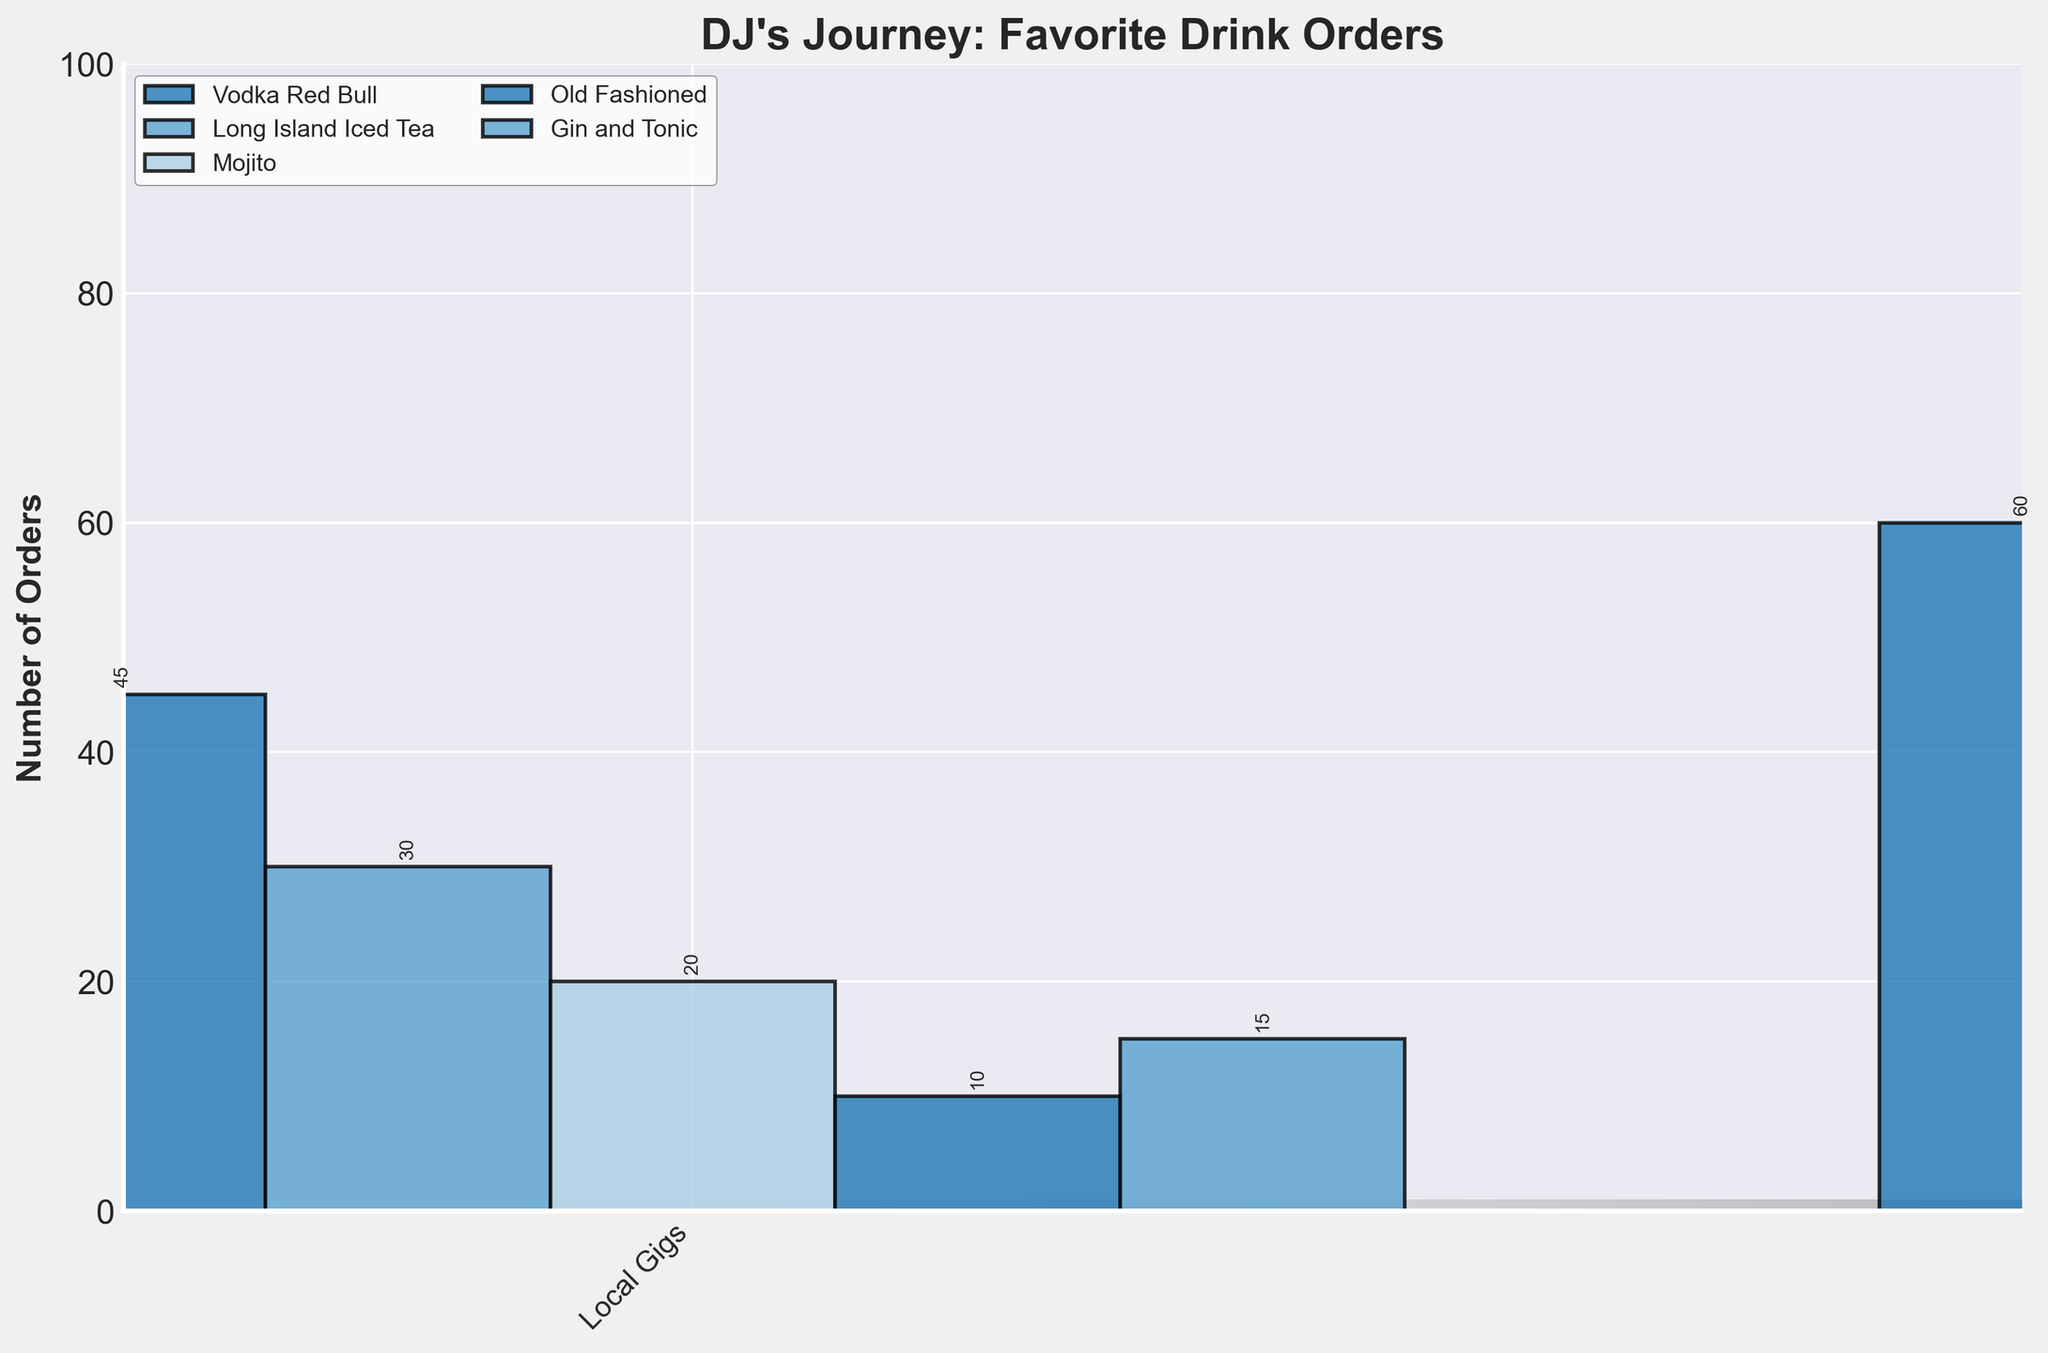Which drink had the most orders during the Grammy Nomination stage? Look for the highest bar in the Grammy Nomination stage section of the plot. The highest bar represents Old Fashioned.
Answer: Old Fashioned What is the total number of orders for Mojitos during Festival Appearances and International Tours stages combined? Sum the Mojito orders at these two stages: 50 (Festival Appearances) + 60 (International Tours) = 110
Answer: 110 How does the number of Old Fashioned orders change from Club Residency to International Tours stages? Subtract the Old Fashioned orders at Club Residency (25) from those at International Tours (55): 55 - 25 = 30
Answer: Increases by 30 Which stage saw the least number of Gin and Tonic orders? Identify the shortest Gin and Tonic bar across all stages. The shortest one is at Local Gigs, with 15 orders.
Answer: Local Gigs Compare Vodka Red Bull orders between Festival Appearances and Grammy Nomination stages. Which stage had more orders, and by how much? Subtract Vodka Red Bull orders at Grammy Nomination (55) from those at Festival Appearances (80). Festival Appearances had more orders by 25 (80 - 55 = 25).
Answer: Festival Appearances by 25 What is the average number of orders for Long Island Iced Tea across all stages? Sum the orders for Long Island Iced Tea at all stages: (30 + 40 + 55 + 65 + 70) = 260. Divide by the number of stages (5): 260 / 5 = 52
Answer: 52 Is there a stage where all drinks have more than 20 orders? Check each drink order at each stage to see if they are all above 20 orders. At Club Residency (second stage), all drink orders are more than 20.
Answer: Club Residency What was the trend in Gin and Tonic orders from Local Gigs to Grammy Nomination? Observe the bars representing Gin and Tonic orders across the stages. Numbers: 15 (Local Gigs), 30 (Club Residency), 45 (Festival Appearances), 50 (International Tours), 60 (Grammy Nomination). The trend is increasing.
Answer: Increasing 